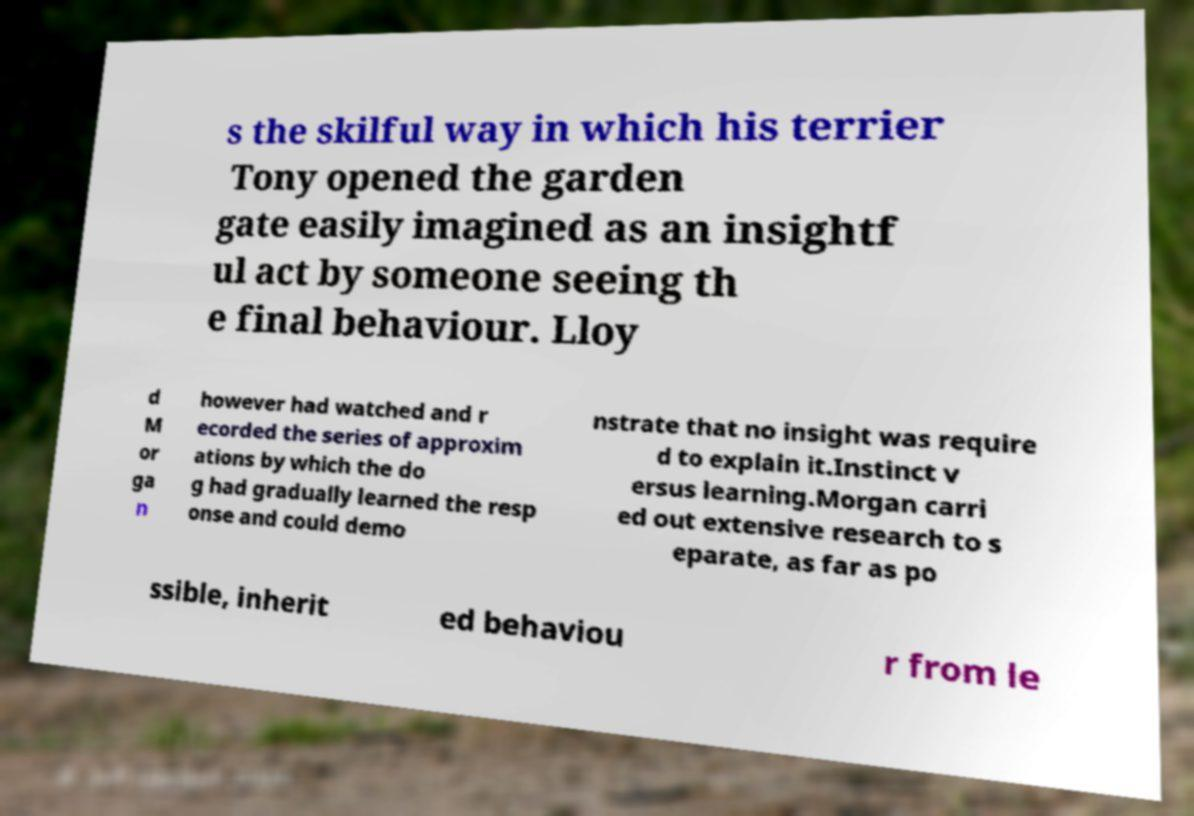There's text embedded in this image that I need extracted. Can you transcribe it verbatim? s the skilful way in which his terrier Tony opened the garden gate easily imagined as an insightf ul act by someone seeing th e final behaviour. Lloy d M or ga n however had watched and r ecorded the series of approxim ations by which the do g had gradually learned the resp onse and could demo nstrate that no insight was require d to explain it.Instinct v ersus learning.Morgan carri ed out extensive research to s eparate, as far as po ssible, inherit ed behaviou r from le 